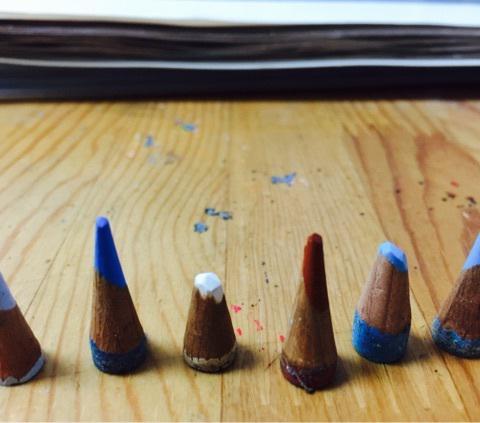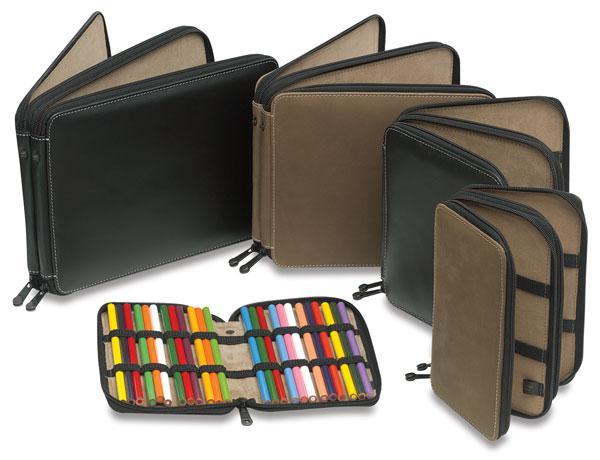The first image is the image on the left, the second image is the image on the right. Evaluate the accuracy of this statement regarding the images: "The pencils in the left image are supported with bands.". Is it true? Answer yes or no. No. 